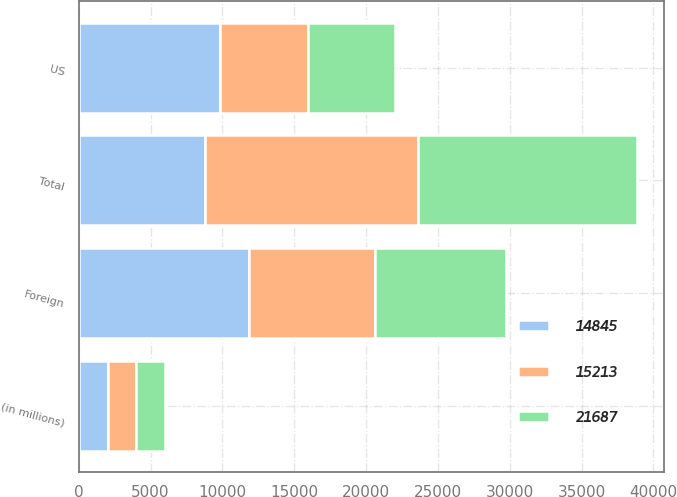Convert chart to OTSL. <chart><loc_0><loc_0><loc_500><loc_500><stacked_bar_chart><ecel><fcel>(in millions)<fcel>US<fcel>Foreign<fcel>Total<nl><fcel>14845<fcel>2006<fcel>9862<fcel>11825<fcel>8776<nl><fcel>21687<fcel>2005<fcel>6103<fcel>9110<fcel>15213<nl><fcel>15213<fcel>2004<fcel>6069<fcel>8776<fcel>14845<nl></chart> 